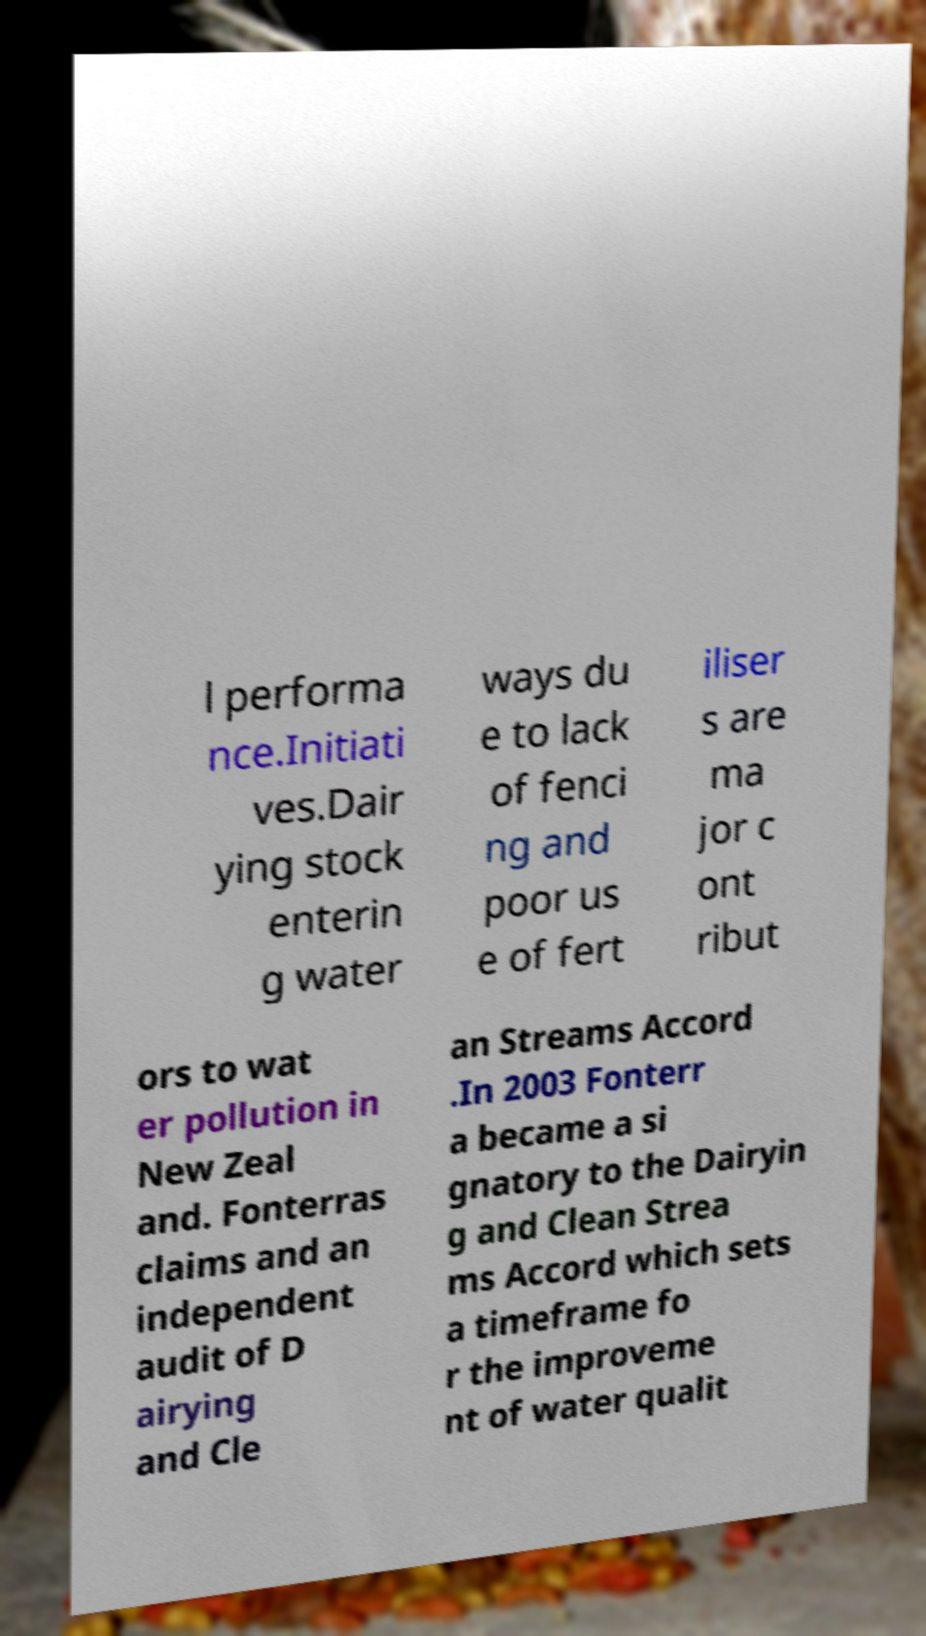Could you extract and type out the text from this image? l performa nce.Initiati ves.Dair ying stock enterin g water ways du e to lack of fenci ng and poor us e of fert iliser s are ma jor c ont ribut ors to wat er pollution in New Zeal and. Fonterras claims and an independent audit of D airying and Cle an Streams Accord .In 2003 Fonterr a became a si gnatory to the Dairyin g and Clean Strea ms Accord which sets a timeframe fo r the improveme nt of water qualit 